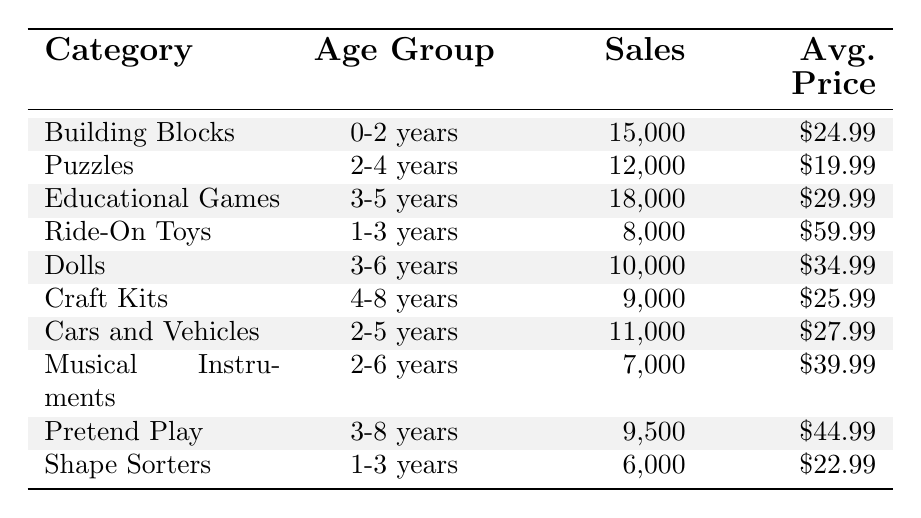What is the sales figure for Building Blocks? The table shows that the sales figure for Building Blocks under the age group 0-2 years is 15,000.
Answer: 15,000 Which toy category has the highest average price? By comparing the average prices in the table, Ride-On Toys have the highest average price at $59.99.
Answer: $59.99 How many total sales were recorded for Educational Games and Dolls combined? Adding the sales figures for Educational Games (18,000) and Dolls (10,000) gives us a total of 28,000.
Answer: 28,000 Is the average price of Puzzles higher than that of Cars and Vehicles? The average price for Puzzles is $19.99, while for Cars and Vehicles it is $27.99. Since $19.99 is less than $27.99, this statement is false.
Answer: No Which age group has the most sales in total? The total sales per age group can be determined by adding the sales of toys for each age group. For example, for 0-2 years: 15,000 (Building Blocks); for 1-3 years: 8,000 (Ride-On Toys) + 6,000 (Shape Sorters) = 14,000; for 2-4 years: 12,000 (Puzzles); and so on. After calculating, the group 3-5 years has the highest total sales of 18,000 (Educational Games) + 10,000 (Dolls) + 11,000 (Cars and Vehicles) = 39,000.
Answer: 3-5 years What is the average price of all toys listed in the table? To find the average price, add the average prices of all toys: $24.99 + $19.99 + $29.99 + $59.99 + $34.99 + $25.99 + $27.99 + $39.99 + $44.99 + $22.99 = $356.90. Then, divide by 10 (the number of categories), resulting in an average of $35.69.
Answer: $35.69 Which category has the lowest sales and what is that figure? Looking through the sales figures provided in the table, Musical Instruments have the lowest sales recorded at 7,000.
Answer: 7,000 If I wanted to buy 2 of the average price toys from the Educational Games category, how much would it cost? The average price of Educational Games is $29.99, so purchasing 2 would cost 2 times $29.99, giving us a total of $59.98.
Answer: $59.98 Are there more sales in the age group 3-8 years compared to 2-4 years? The total sales for 3-8 years (including Pretend Play and Dolls) is 9,500 (Pretend Play) + 10,000 (Dolls) = 19,500, while for 2-4 years (Puzzles) the sales is 12,000. Since 19,500 is greater than 12,000, the statement is true.
Answer: Yes What is the difference in sales between Ride-On Toys and Shape Sorters? Ride-On Toys have sales of 8,000 while Shape Sorters have 6,000. The difference is calculated as 8,000 - 6,000 = 2,000.
Answer: 2,000 